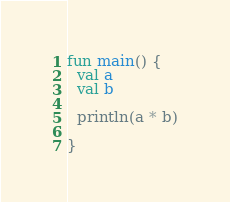<code> <loc_0><loc_0><loc_500><loc_500><_Kotlin_>fun main() {
  val a
  val b
   
  println(a * b)

}</code> 